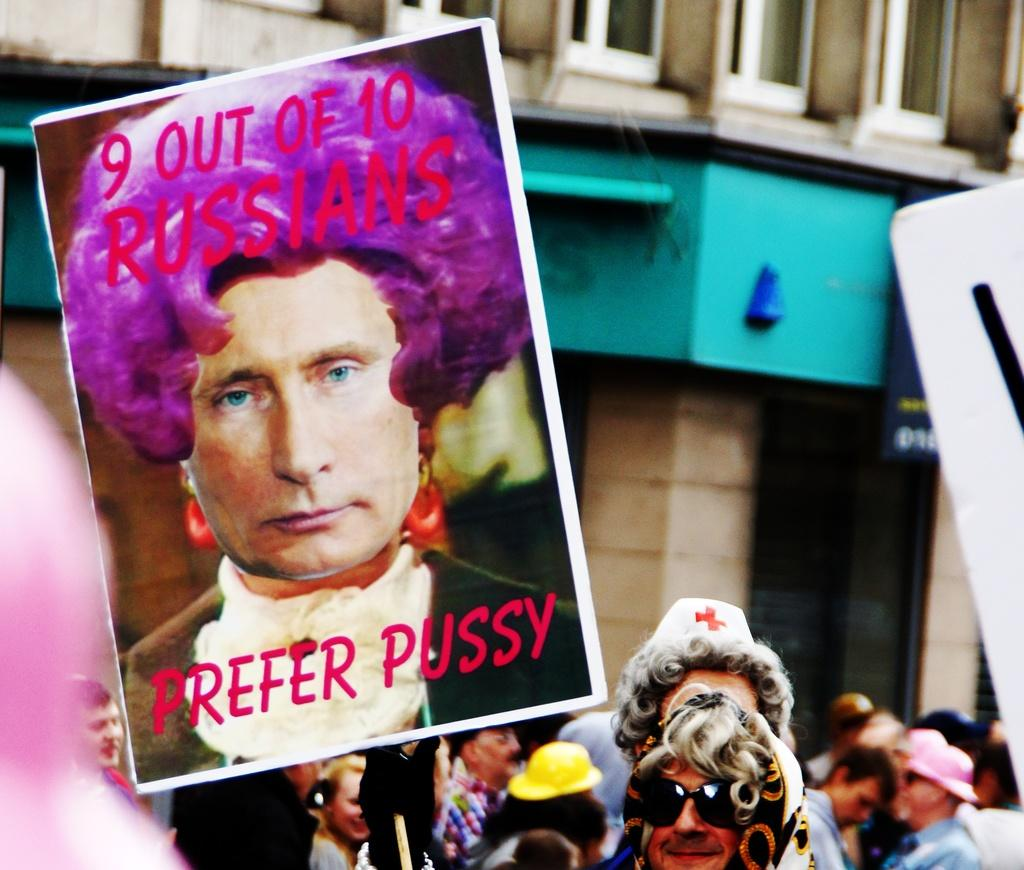How many people are in the image? There are people in the image, but the exact number cannot be determined from the provided facts. What is the main object in the image? There is a board in the image. What can be seen on the right side of the image? There is a white object on the right side of the image. What architectural feature is visible in the background of the image? There is a pillar in the background of the image. What else can be seen in the background of the image? There are windows and another board in the background of the image. What type of grape is being used as a plate in the image? There is no grape or plate present in the image. What reward is being given to the people in the image? There is no indication of a reward being given to the people in the image. 